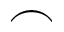Convert formula to latex. <formula><loc_0><loc_0><loc_500><loc_500>\frown</formula> 